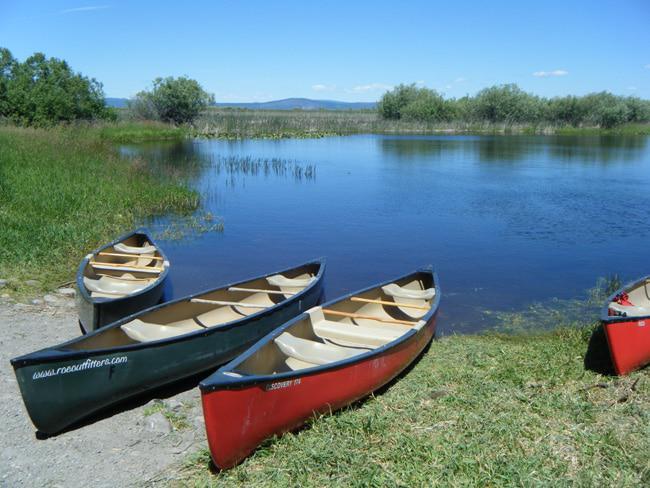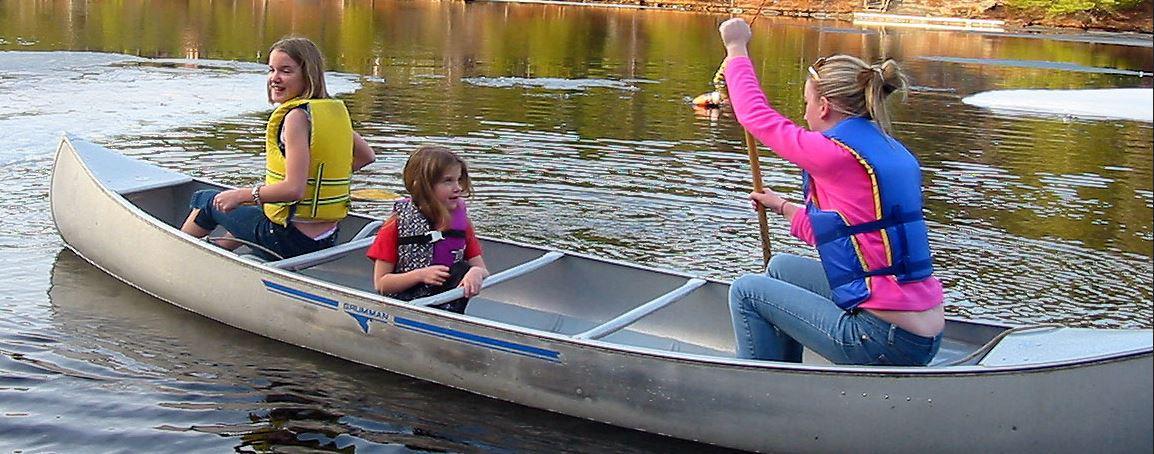The first image is the image on the left, the second image is the image on the right. For the images shown, is this caption "An image shows a wooden item attached to an end of a boat, by green ground instead of water." true? Answer yes or no. No. The first image is the image on the left, the second image is the image on the right. Considering the images on both sides, is "At least one person is in a green canoe on the water." valid? Answer yes or no. No. 